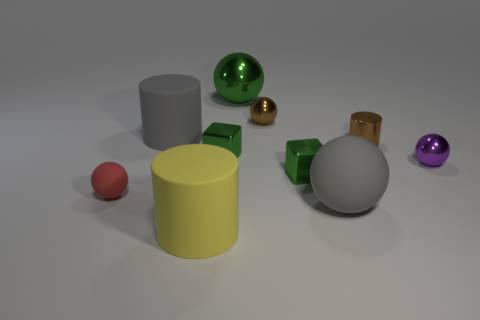Subtract 2 spheres. How many spheres are left? 3 Subtract all red balls. How many balls are left? 4 Subtract all brown shiny spheres. How many spheres are left? 4 Subtract all green spheres. Subtract all blue blocks. How many spheres are left? 4 Subtract all blocks. How many objects are left? 8 Subtract 1 yellow cylinders. How many objects are left? 9 Subtract all rubber cylinders. Subtract all tiny purple shiny balls. How many objects are left? 7 Add 3 small green shiny objects. How many small green shiny objects are left? 5 Add 7 red blocks. How many red blocks exist? 7 